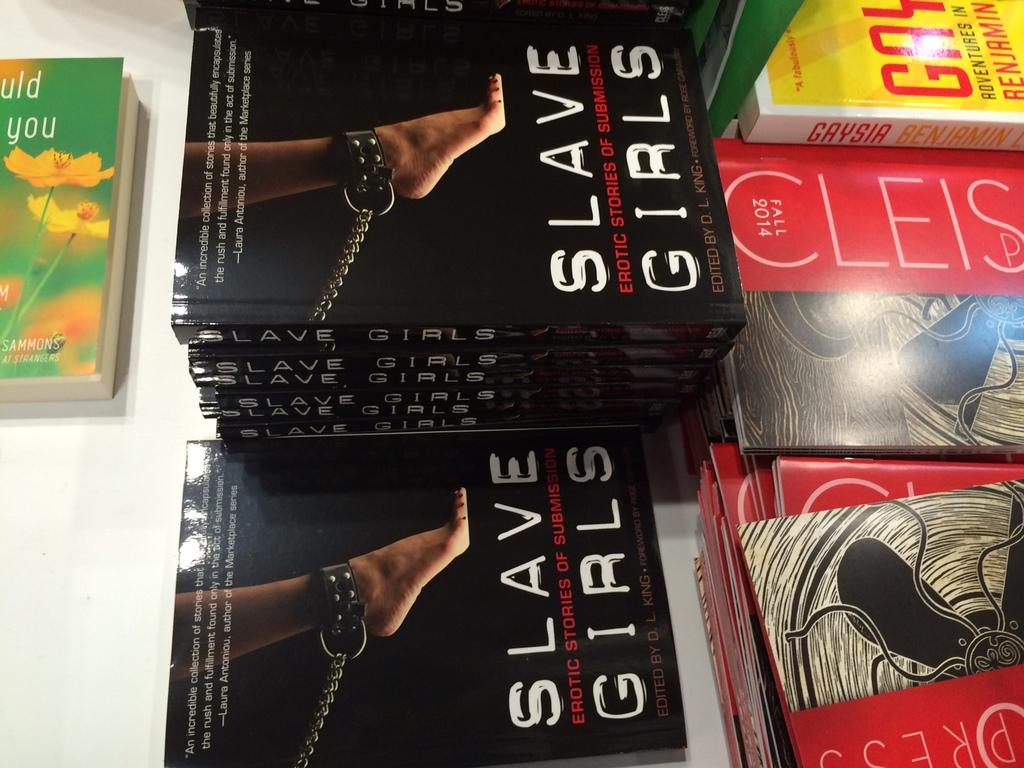What's the title of the books in the middle?
Ensure brevity in your answer.  Slave girls. What is the title or author of the red book?
Offer a terse response. Cleis. 